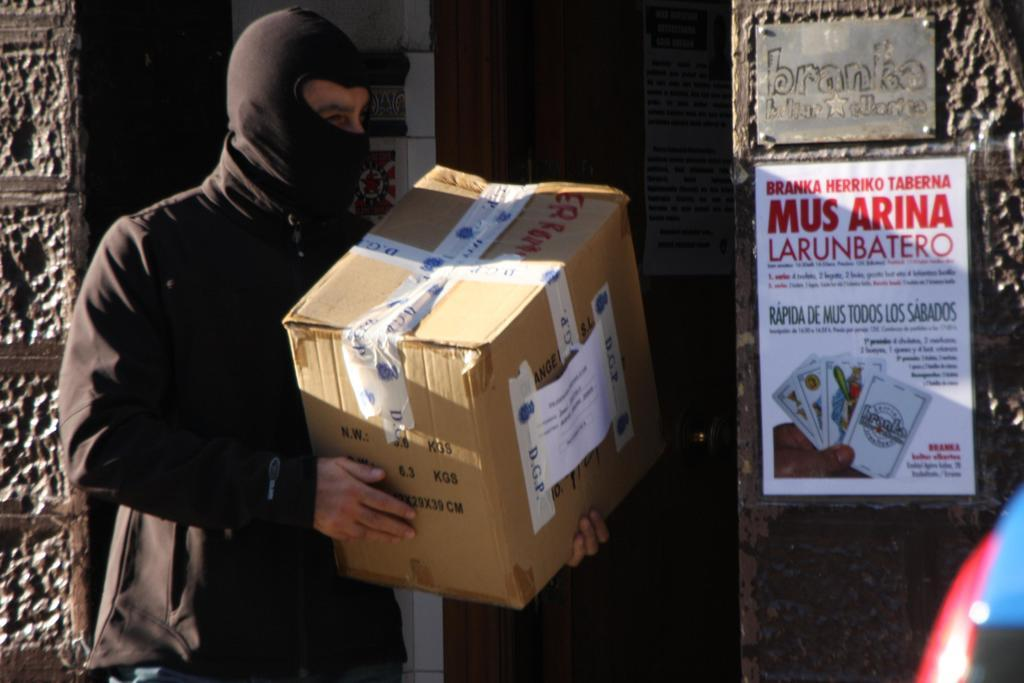What is the man in the image doing? The man is standing in the image and holding a cardboard box. What is the man wearing in the image? The man is wearing a mask in the image. What can be seen on the wall in the image? There is a board and a poster on the wall in the image. Can you describe the poster visible in the background of the image? There is a poster visible in the background of the image, but its content is not clear from the provided facts. What type of pets can be seen playing with a bean in the image? There are no pets or beans present in the image. 